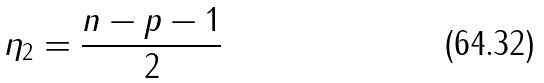Convert formula to latex. <formula><loc_0><loc_0><loc_500><loc_500>\eta _ { 2 } = \frac { n - p - 1 } { 2 }</formula> 